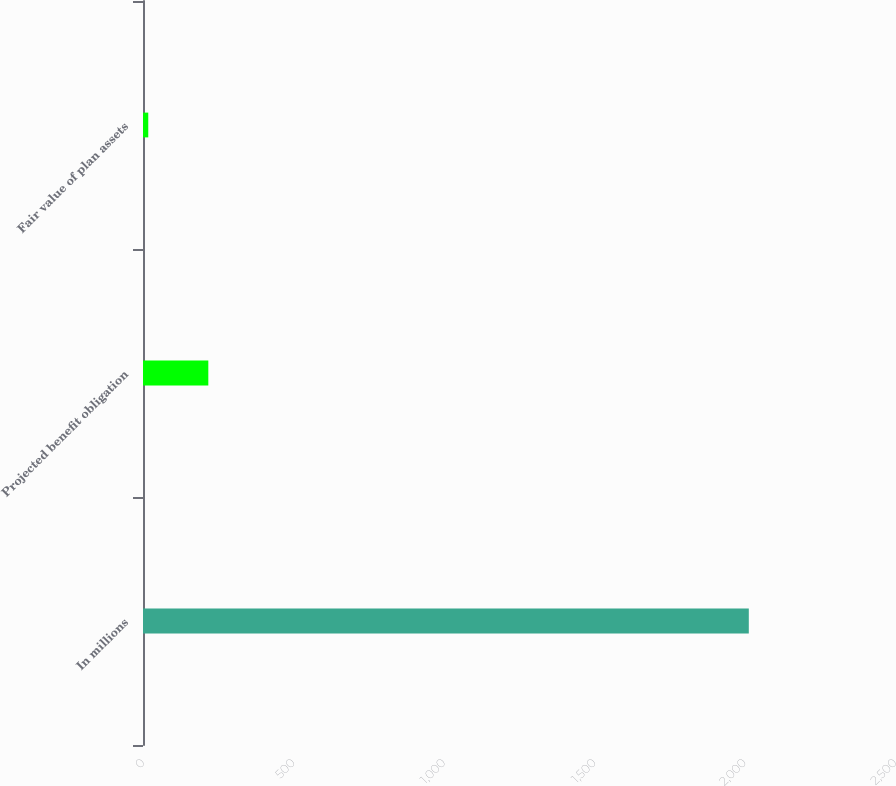<chart> <loc_0><loc_0><loc_500><loc_500><bar_chart><fcel>In millions<fcel>Projected benefit obligation<fcel>Fair value of plan assets<nl><fcel>2014<fcel>217.15<fcel>17.5<nl></chart> 